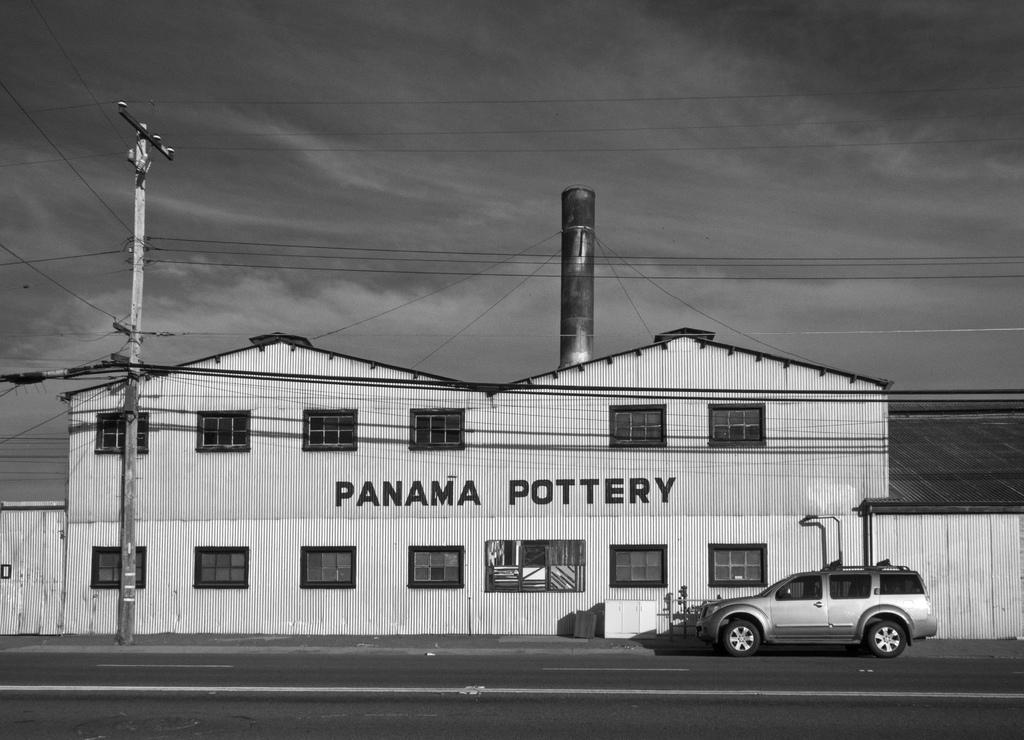What is on the road in the image? There is a vehicle on the road in the image. What type of structure can be seen in the image? There is a building in the image. What else is present in the image besides the vehicle and building? There is an electric pole in the image. What can be seen in the background of the image? The sky is visible in the background of the image. Can you tell me how many snails are crawling on the vehicle in the image? There are no snails present in the image; it only features a vehicle, a building, an electric pole, and the sky. What type of cake is being served at the event happening in the image? There is no event or cake present in the image. 